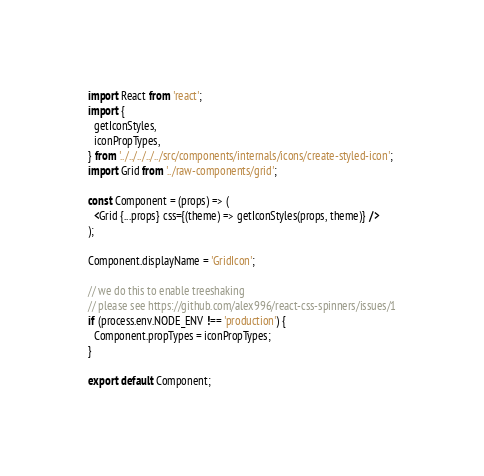Convert code to text. <code><loc_0><loc_0><loc_500><loc_500><_JavaScript_>import React from 'react';
import {
  getIconStyles,
  iconPropTypes,
} from '../../../../../src/components/internals/icons/create-styled-icon';
import Grid from '../raw-components/grid';

const Component = (props) => (
  <Grid {...props} css={(theme) => getIconStyles(props, theme)} />
);

Component.displayName = 'GridIcon';

// we do this to enable treeshaking
// please see https://github.com/alex996/react-css-spinners/issues/1
if (process.env.NODE_ENV !== 'production') {
  Component.propTypes = iconPropTypes;
}

export default Component;
</code> 